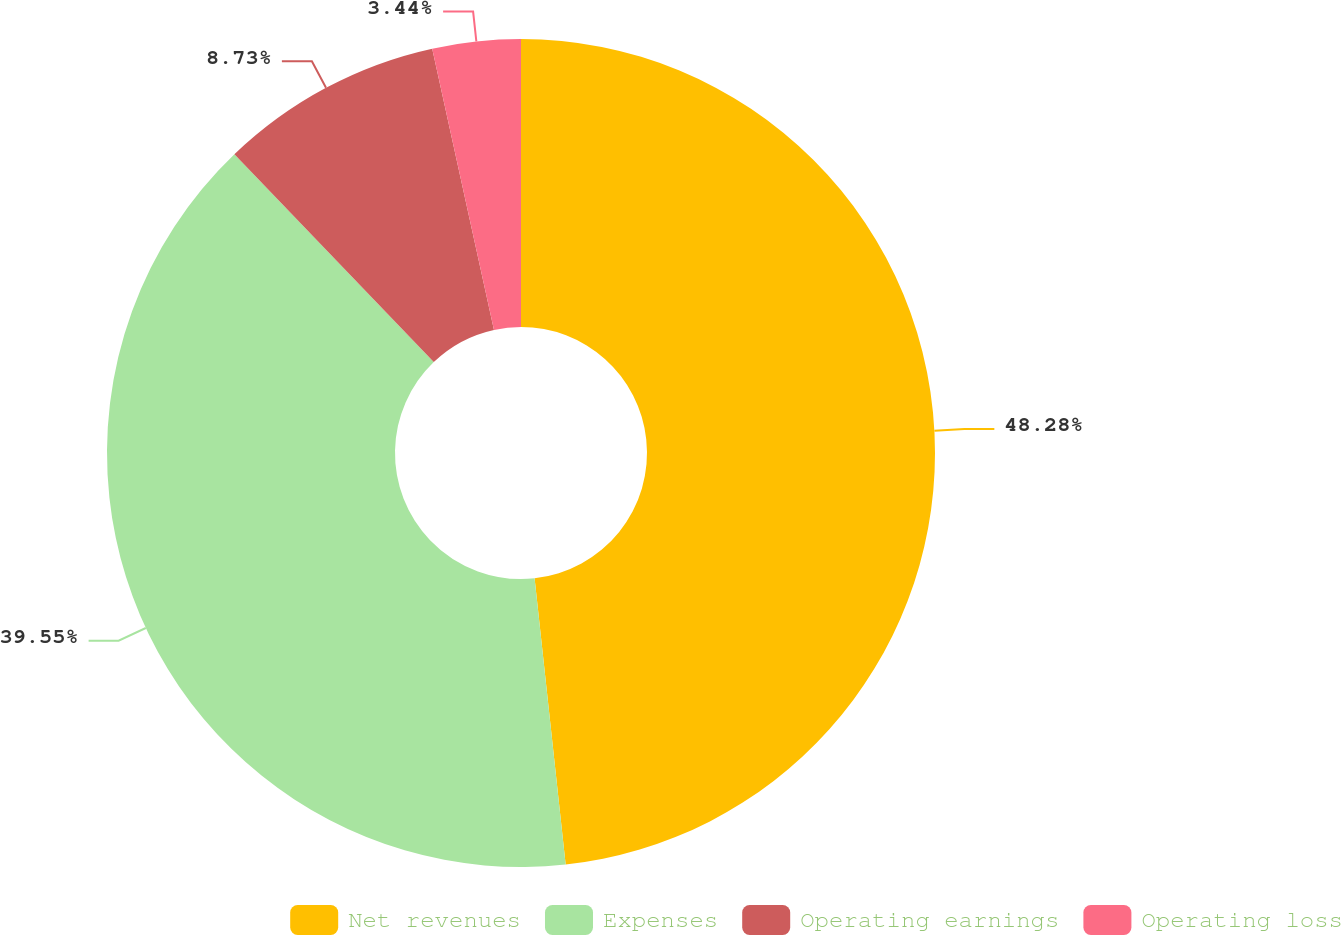Convert chart. <chart><loc_0><loc_0><loc_500><loc_500><pie_chart><fcel>Net revenues<fcel>Expenses<fcel>Operating earnings<fcel>Operating loss<nl><fcel>48.28%<fcel>39.55%<fcel>8.73%<fcel>3.44%<nl></chart> 